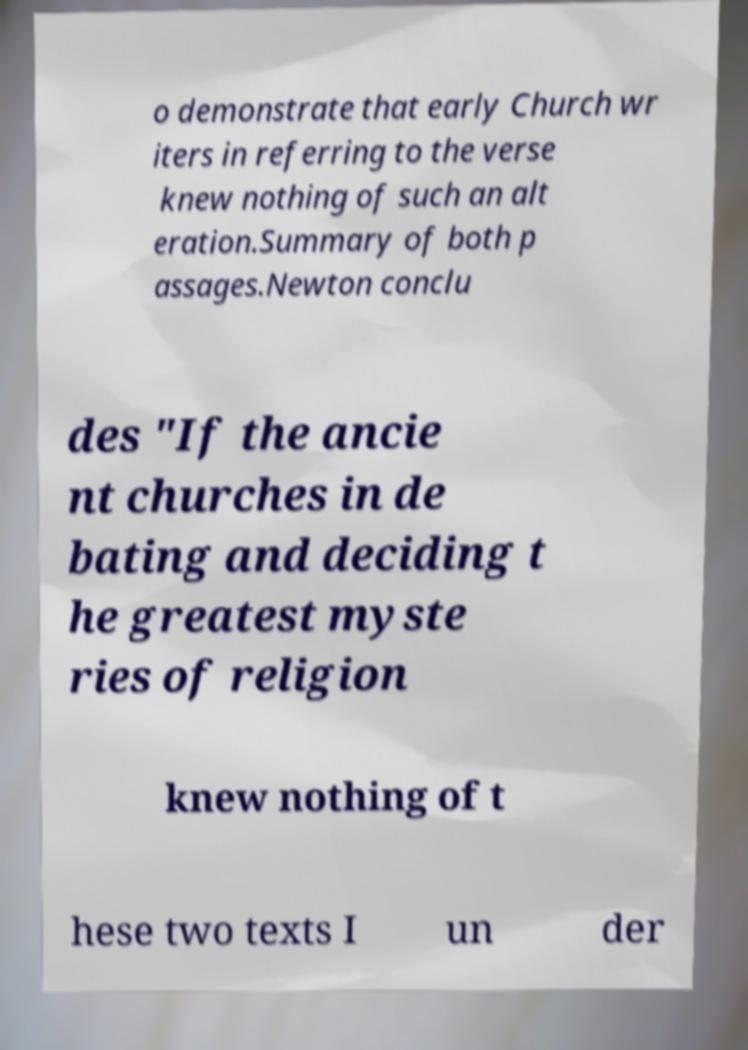Please identify and transcribe the text found in this image. o demonstrate that early Church wr iters in referring to the verse knew nothing of such an alt eration.Summary of both p assages.Newton conclu des "If the ancie nt churches in de bating and deciding t he greatest myste ries of religion knew nothing of t hese two texts I un der 